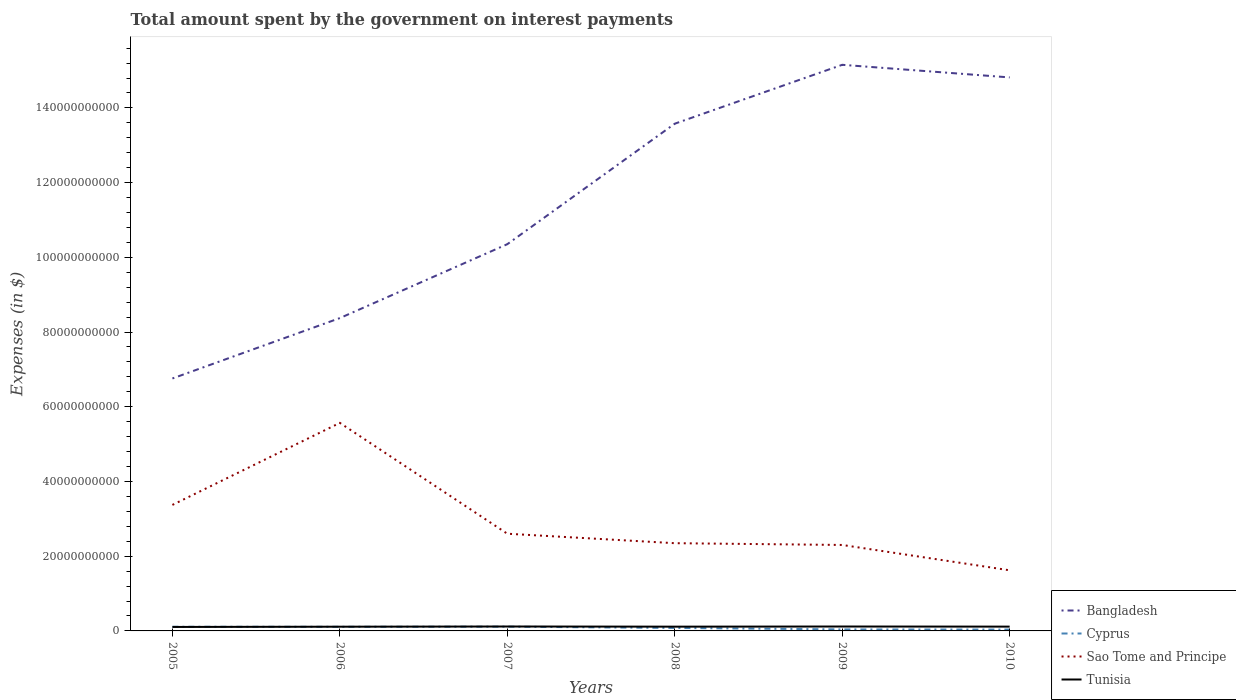Does the line corresponding to Tunisia intersect with the line corresponding to Cyprus?
Provide a succinct answer. Yes. Is the number of lines equal to the number of legend labels?
Offer a very short reply. Yes. Across all years, what is the maximum amount spent on interest payments by the government in Tunisia?
Your answer should be very brief. 1.06e+09. What is the total amount spent on interest payments by the government in Bangladesh in the graph?
Make the answer very short. -1.98e+1. What is the difference between the highest and the second highest amount spent on interest payments by the government in Sao Tome and Principe?
Ensure brevity in your answer.  3.95e+1. What is the difference between the highest and the lowest amount spent on interest payments by the government in Tunisia?
Offer a very short reply. 4. What is the difference between two consecutive major ticks on the Y-axis?
Your response must be concise. 2.00e+1. Are the values on the major ticks of Y-axis written in scientific E-notation?
Provide a short and direct response. No. Does the graph contain any zero values?
Keep it short and to the point. No. How many legend labels are there?
Give a very brief answer. 4. How are the legend labels stacked?
Offer a very short reply. Vertical. What is the title of the graph?
Offer a terse response. Total amount spent by the government on interest payments. Does "Croatia" appear as one of the legend labels in the graph?
Your response must be concise. No. What is the label or title of the Y-axis?
Your answer should be very brief. Expenses (in $). What is the Expenses (in $) in Bangladesh in 2005?
Ensure brevity in your answer.  6.76e+1. What is the Expenses (in $) in Cyprus in 2005?
Keep it short and to the point. 1.11e+09. What is the Expenses (in $) of Sao Tome and Principe in 2005?
Your answer should be very brief. 3.37e+1. What is the Expenses (in $) in Tunisia in 2005?
Provide a short and direct response. 1.06e+09. What is the Expenses (in $) in Bangladesh in 2006?
Your response must be concise. 8.37e+1. What is the Expenses (in $) of Cyprus in 2006?
Offer a very short reply. 1.10e+09. What is the Expenses (in $) of Sao Tome and Principe in 2006?
Ensure brevity in your answer.  5.57e+1. What is the Expenses (in $) of Tunisia in 2006?
Your answer should be compact. 1.13e+09. What is the Expenses (in $) in Bangladesh in 2007?
Offer a very short reply. 1.04e+11. What is the Expenses (in $) of Cyprus in 2007?
Provide a succinct answer. 1.14e+09. What is the Expenses (in $) of Sao Tome and Principe in 2007?
Provide a succinct answer. 2.60e+1. What is the Expenses (in $) in Tunisia in 2007?
Make the answer very short. 1.18e+09. What is the Expenses (in $) of Bangladesh in 2008?
Make the answer very short. 1.36e+11. What is the Expenses (in $) in Cyprus in 2008?
Keep it short and to the point. 7.95e+08. What is the Expenses (in $) in Sao Tome and Principe in 2008?
Your answer should be compact. 2.35e+1. What is the Expenses (in $) of Tunisia in 2008?
Your answer should be compact. 1.14e+09. What is the Expenses (in $) of Bangladesh in 2009?
Provide a short and direct response. 1.52e+11. What is the Expenses (in $) in Cyprus in 2009?
Offer a terse response. 4.03e+08. What is the Expenses (in $) in Sao Tome and Principe in 2009?
Provide a succinct answer. 2.30e+1. What is the Expenses (in $) in Tunisia in 2009?
Your answer should be compact. 1.18e+09. What is the Expenses (in $) in Bangladesh in 2010?
Offer a very short reply. 1.48e+11. What is the Expenses (in $) of Cyprus in 2010?
Your response must be concise. 3.62e+08. What is the Expenses (in $) in Sao Tome and Principe in 2010?
Your response must be concise. 1.62e+1. What is the Expenses (in $) of Tunisia in 2010?
Offer a very short reply. 1.15e+09. Across all years, what is the maximum Expenses (in $) of Bangladesh?
Keep it short and to the point. 1.52e+11. Across all years, what is the maximum Expenses (in $) in Cyprus?
Offer a very short reply. 1.14e+09. Across all years, what is the maximum Expenses (in $) of Sao Tome and Principe?
Give a very brief answer. 5.57e+1. Across all years, what is the maximum Expenses (in $) in Tunisia?
Offer a very short reply. 1.18e+09. Across all years, what is the minimum Expenses (in $) of Bangladesh?
Your answer should be very brief. 6.76e+1. Across all years, what is the minimum Expenses (in $) in Cyprus?
Give a very brief answer. 3.62e+08. Across all years, what is the minimum Expenses (in $) of Sao Tome and Principe?
Provide a short and direct response. 1.62e+1. Across all years, what is the minimum Expenses (in $) in Tunisia?
Your answer should be compact. 1.06e+09. What is the total Expenses (in $) in Bangladesh in the graph?
Ensure brevity in your answer.  6.90e+11. What is the total Expenses (in $) of Cyprus in the graph?
Your answer should be very brief. 4.92e+09. What is the total Expenses (in $) in Sao Tome and Principe in the graph?
Offer a very short reply. 1.78e+11. What is the total Expenses (in $) of Tunisia in the graph?
Provide a succinct answer. 6.85e+09. What is the difference between the Expenses (in $) of Bangladesh in 2005 and that in 2006?
Ensure brevity in your answer.  -1.62e+1. What is the difference between the Expenses (in $) in Cyprus in 2005 and that in 2006?
Make the answer very short. 1.20e+07. What is the difference between the Expenses (in $) in Sao Tome and Principe in 2005 and that in 2006?
Give a very brief answer. -2.20e+1. What is the difference between the Expenses (in $) in Tunisia in 2005 and that in 2006?
Keep it short and to the point. -6.77e+07. What is the difference between the Expenses (in $) in Bangladesh in 2005 and that in 2007?
Your answer should be compact. -3.59e+1. What is the difference between the Expenses (in $) of Cyprus in 2005 and that in 2007?
Offer a terse response. -2.79e+07. What is the difference between the Expenses (in $) of Sao Tome and Principe in 2005 and that in 2007?
Your response must be concise. 7.71e+09. What is the difference between the Expenses (in $) in Tunisia in 2005 and that in 2007?
Your answer should be very brief. -1.20e+08. What is the difference between the Expenses (in $) in Bangladesh in 2005 and that in 2008?
Give a very brief answer. -6.82e+1. What is the difference between the Expenses (in $) of Cyprus in 2005 and that in 2008?
Give a very brief answer. 3.19e+08. What is the difference between the Expenses (in $) in Sao Tome and Principe in 2005 and that in 2008?
Ensure brevity in your answer.  1.02e+1. What is the difference between the Expenses (in $) in Tunisia in 2005 and that in 2008?
Offer a very short reply. -8.04e+07. What is the difference between the Expenses (in $) in Bangladesh in 2005 and that in 2009?
Your response must be concise. -8.40e+1. What is the difference between the Expenses (in $) of Cyprus in 2005 and that in 2009?
Keep it short and to the point. 7.11e+08. What is the difference between the Expenses (in $) in Sao Tome and Principe in 2005 and that in 2009?
Provide a succinct answer. 1.07e+1. What is the difference between the Expenses (in $) in Tunisia in 2005 and that in 2009?
Ensure brevity in your answer.  -1.18e+08. What is the difference between the Expenses (in $) in Bangladesh in 2005 and that in 2010?
Provide a short and direct response. -8.06e+1. What is the difference between the Expenses (in $) in Cyprus in 2005 and that in 2010?
Offer a very short reply. 7.53e+08. What is the difference between the Expenses (in $) of Sao Tome and Principe in 2005 and that in 2010?
Give a very brief answer. 1.75e+1. What is the difference between the Expenses (in $) in Tunisia in 2005 and that in 2010?
Give a very brief answer. -8.99e+07. What is the difference between the Expenses (in $) in Bangladesh in 2006 and that in 2007?
Your answer should be very brief. -1.98e+1. What is the difference between the Expenses (in $) of Cyprus in 2006 and that in 2007?
Make the answer very short. -3.98e+07. What is the difference between the Expenses (in $) in Sao Tome and Principe in 2006 and that in 2007?
Your response must be concise. 2.97e+1. What is the difference between the Expenses (in $) of Tunisia in 2006 and that in 2007?
Ensure brevity in your answer.  -5.21e+07. What is the difference between the Expenses (in $) in Bangladesh in 2006 and that in 2008?
Keep it short and to the point. -5.20e+1. What is the difference between the Expenses (in $) of Cyprus in 2006 and that in 2008?
Your answer should be very brief. 3.07e+08. What is the difference between the Expenses (in $) in Sao Tome and Principe in 2006 and that in 2008?
Offer a very short reply. 3.22e+1. What is the difference between the Expenses (in $) in Tunisia in 2006 and that in 2008?
Keep it short and to the point. -1.27e+07. What is the difference between the Expenses (in $) of Bangladesh in 2006 and that in 2009?
Keep it short and to the point. -6.78e+1. What is the difference between the Expenses (in $) in Cyprus in 2006 and that in 2009?
Keep it short and to the point. 6.99e+08. What is the difference between the Expenses (in $) of Sao Tome and Principe in 2006 and that in 2009?
Your answer should be compact. 3.27e+1. What is the difference between the Expenses (in $) in Tunisia in 2006 and that in 2009?
Keep it short and to the point. -5.03e+07. What is the difference between the Expenses (in $) of Bangladesh in 2006 and that in 2010?
Provide a short and direct response. -6.44e+1. What is the difference between the Expenses (in $) of Cyprus in 2006 and that in 2010?
Provide a succinct answer. 7.41e+08. What is the difference between the Expenses (in $) in Sao Tome and Principe in 2006 and that in 2010?
Ensure brevity in your answer.  3.95e+1. What is the difference between the Expenses (in $) in Tunisia in 2006 and that in 2010?
Your response must be concise. -2.22e+07. What is the difference between the Expenses (in $) of Bangladesh in 2007 and that in 2008?
Offer a terse response. -3.23e+1. What is the difference between the Expenses (in $) in Cyprus in 2007 and that in 2008?
Your response must be concise. 3.47e+08. What is the difference between the Expenses (in $) of Sao Tome and Principe in 2007 and that in 2008?
Provide a succinct answer. 2.54e+09. What is the difference between the Expenses (in $) of Tunisia in 2007 and that in 2008?
Your response must be concise. 3.94e+07. What is the difference between the Expenses (in $) in Bangladesh in 2007 and that in 2009?
Your answer should be compact. -4.80e+1. What is the difference between the Expenses (in $) of Cyprus in 2007 and that in 2009?
Offer a very short reply. 7.39e+08. What is the difference between the Expenses (in $) of Sao Tome and Principe in 2007 and that in 2009?
Give a very brief answer. 3.01e+09. What is the difference between the Expenses (in $) of Tunisia in 2007 and that in 2009?
Provide a short and direct response. 1.80e+06. What is the difference between the Expenses (in $) of Bangladesh in 2007 and that in 2010?
Your response must be concise. -4.46e+1. What is the difference between the Expenses (in $) in Cyprus in 2007 and that in 2010?
Your response must be concise. 7.80e+08. What is the difference between the Expenses (in $) of Sao Tome and Principe in 2007 and that in 2010?
Your response must be concise. 9.79e+09. What is the difference between the Expenses (in $) of Tunisia in 2007 and that in 2010?
Make the answer very short. 2.99e+07. What is the difference between the Expenses (in $) of Bangladesh in 2008 and that in 2009?
Your answer should be very brief. -1.58e+1. What is the difference between the Expenses (in $) in Cyprus in 2008 and that in 2009?
Offer a very short reply. 3.92e+08. What is the difference between the Expenses (in $) in Sao Tome and Principe in 2008 and that in 2009?
Your answer should be compact. 4.73e+08. What is the difference between the Expenses (in $) in Tunisia in 2008 and that in 2009?
Your answer should be compact. -3.76e+07. What is the difference between the Expenses (in $) in Bangladesh in 2008 and that in 2010?
Ensure brevity in your answer.  -1.24e+1. What is the difference between the Expenses (in $) of Cyprus in 2008 and that in 2010?
Your answer should be compact. 4.34e+08. What is the difference between the Expenses (in $) of Sao Tome and Principe in 2008 and that in 2010?
Keep it short and to the point. 7.26e+09. What is the difference between the Expenses (in $) of Tunisia in 2008 and that in 2010?
Keep it short and to the point. -9.50e+06. What is the difference between the Expenses (in $) in Bangladesh in 2009 and that in 2010?
Offer a very short reply. 3.37e+09. What is the difference between the Expenses (in $) in Cyprus in 2009 and that in 2010?
Offer a terse response. 4.11e+07. What is the difference between the Expenses (in $) in Sao Tome and Principe in 2009 and that in 2010?
Make the answer very short. 6.78e+09. What is the difference between the Expenses (in $) in Tunisia in 2009 and that in 2010?
Give a very brief answer. 2.81e+07. What is the difference between the Expenses (in $) in Bangladesh in 2005 and the Expenses (in $) in Cyprus in 2006?
Give a very brief answer. 6.65e+1. What is the difference between the Expenses (in $) of Bangladesh in 2005 and the Expenses (in $) of Sao Tome and Principe in 2006?
Give a very brief answer. 1.19e+1. What is the difference between the Expenses (in $) in Bangladesh in 2005 and the Expenses (in $) in Tunisia in 2006?
Provide a short and direct response. 6.64e+1. What is the difference between the Expenses (in $) of Cyprus in 2005 and the Expenses (in $) of Sao Tome and Principe in 2006?
Offer a very short reply. -5.46e+1. What is the difference between the Expenses (in $) in Cyprus in 2005 and the Expenses (in $) in Tunisia in 2006?
Provide a short and direct response. -1.58e+07. What is the difference between the Expenses (in $) in Sao Tome and Principe in 2005 and the Expenses (in $) in Tunisia in 2006?
Keep it short and to the point. 3.26e+1. What is the difference between the Expenses (in $) of Bangladesh in 2005 and the Expenses (in $) of Cyprus in 2007?
Your response must be concise. 6.64e+1. What is the difference between the Expenses (in $) in Bangladesh in 2005 and the Expenses (in $) in Sao Tome and Principe in 2007?
Make the answer very short. 4.16e+1. What is the difference between the Expenses (in $) in Bangladesh in 2005 and the Expenses (in $) in Tunisia in 2007?
Offer a terse response. 6.64e+1. What is the difference between the Expenses (in $) of Cyprus in 2005 and the Expenses (in $) of Sao Tome and Principe in 2007?
Provide a short and direct response. -2.49e+1. What is the difference between the Expenses (in $) of Cyprus in 2005 and the Expenses (in $) of Tunisia in 2007?
Your response must be concise. -6.79e+07. What is the difference between the Expenses (in $) in Sao Tome and Principe in 2005 and the Expenses (in $) in Tunisia in 2007?
Offer a terse response. 3.25e+1. What is the difference between the Expenses (in $) in Bangladesh in 2005 and the Expenses (in $) in Cyprus in 2008?
Offer a very short reply. 6.68e+1. What is the difference between the Expenses (in $) of Bangladesh in 2005 and the Expenses (in $) of Sao Tome and Principe in 2008?
Provide a short and direct response. 4.41e+1. What is the difference between the Expenses (in $) in Bangladesh in 2005 and the Expenses (in $) in Tunisia in 2008?
Provide a succinct answer. 6.64e+1. What is the difference between the Expenses (in $) of Cyprus in 2005 and the Expenses (in $) of Sao Tome and Principe in 2008?
Ensure brevity in your answer.  -2.24e+1. What is the difference between the Expenses (in $) of Cyprus in 2005 and the Expenses (in $) of Tunisia in 2008?
Keep it short and to the point. -2.85e+07. What is the difference between the Expenses (in $) of Sao Tome and Principe in 2005 and the Expenses (in $) of Tunisia in 2008?
Give a very brief answer. 3.26e+1. What is the difference between the Expenses (in $) of Bangladesh in 2005 and the Expenses (in $) of Cyprus in 2009?
Ensure brevity in your answer.  6.72e+1. What is the difference between the Expenses (in $) in Bangladesh in 2005 and the Expenses (in $) in Sao Tome and Principe in 2009?
Ensure brevity in your answer.  4.46e+1. What is the difference between the Expenses (in $) of Bangladesh in 2005 and the Expenses (in $) of Tunisia in 2009?
Keep it short and to the point. 6.64e+1. What is the difference between the Expenses (in $) of Cyprus in 2005 and the Expenses (in $) of Sao Tome and Principe in 2009?
Your answer should be very brief. -2.19e+1. What is the difference between the Expenses (in $) in Cyprus in 2005 and the Expenses (in $) in Tunisia in 2009?
Ensure brevity in your answer.  -6.61e+07. What is the difference between the Expenses (in $) in Sao Tome and Principe in 2005 and the Expenses (in $) in Tunisia in 2009?
Make the answer very short. 3.25e+1. What is the difference between the Expenses (in $) in Bangladesh in 2005 and the Expenses (in $) in Cyprus in 2010?
Your answer should be compact. 6.72e+1. What is the difference between the Expenses (in $) in Bangladesh in 2005 and the Expenses (in $) in Sao Tome and Principe in 2010?
Keep it short and to the point. 5.14e+1. What is the difference between the Expenses (in $) of Bangladesh in 2005 and the Expenses (in $) of Tunisia in 2010?
Your response must be concise. 6.64e+1. What is the difference between the Expenses (in $) of Cyprus in 2005 and the Expenses (in $) of Sao Tome and Principe in 2010?
Your response must be concise. -1.51e+1. What is the difference between the Expenses (in $) of Cyprus in 2005 and the Expenses (in $) of Tunisia in 2010?
Offer a terse response. -3.80e+07. What is the difference between the Expenses (in $) of Sao Tome and Principe in 2005 and the Expenses (in $) of Tunisia in 2010?
Your response must be concise. 3.26e+1. What is the difference between the Expenses (in $) of Bangladesh in 2006 and the Expenses (in $) of Cyprus in 2007?
Offer a terse response. 8.26e+1. What is the difference between the Expenses (in $) in Bangladesh in 2006 and the Expenses (in $) in Sao Tome and Principe in 2007?
Offer a terse response. 5.77e+1. What is the difference between the Expenses (in $) of Bangladesh in 2006 and the Expenses (in $) of Tunisia in 2007?
Your response must be concise. 8.26e+1. What is the difference between the Expenses (in $) in Cyprus in 2006 and the Expenses (in $) in Sao Tome and Principe in 2007?
Ensure brevity in your answer.  -2.49e+1. What is the difference between the Expenses (in $) in Cyprus in 2006 and the Expenses (in $) in Tunisia in 2007?
Give a very brief answer. -7.99e+07. What is the difference between the Expenses (in $) in Sao Tome and Principe in 2006 and the Expenses (in $) in Tunisia in 2007?
Provide a succinct answer. 5.45e+1. What is the difference between the Expenses (in $) of Bangladesh in 2006 and the Expenses (in $) of Cyprus in 2008?
Offer a very short reply. 8.29e+1. What is the difference between the Expenses (in $) in Bangladesh in 2006 and the Expenses (in $) in Sao Tome and Principe in 2008?
Your answer should be very brief. 6.03e+1. What is the difference between the Expenses (in $) in Bangladesh in 2006 and the Expenses (in $) in Tunisia in 2008?
Offer a terse response. 8.26e+1. What is the difference between the Expenses (in $) in Cyprus in 2006 and the Expenses (in $) in Sao Tome and Principe in 2008?
Offer a terse response. -2.24e+1. What is the difference between the Expenses (in $) of Cyprus in 2006 and the Expenses (in $) of Tunisia in 2008?
Make the answer very short. -4.05e+07. What is the difference between the Expenses (in $) in Sao Tome and Principe in 2006 and the Expenses (in $) in Tunisia in 2008?
Your response must be concise. 5.45e+1. What is the difference between the Expenses (in $) in Bangladesh in 2006 and the Expenses (in $) in Cyprus in 2009?
Provide a short and direct response. 8.33e+1. What is the difference between the Expenses (in $) of Bangladesh in 2006 and the Expenses (in $) of Sao Tome and Principe in 2009?
Offer a terse response. 6.07e+1. What is the difference between the Expenses (in $) of Bangladesh in 2006 and the Expenses (in $) of Tunisia in 2009?
Give a very brief answer. 8.26e+1. What is the difference between the Expenses (in $) of Cyprus in 2006 and the Expenses (in $) of Sao Tome and Principe in 2009?
Give a very brief answer. -2.19e+1. What is the difference between the Expenses (in $) in Cyprus in 2006 and the Expenses (in $) in Tunisia in 2009?
Your response must be concise. -7.81e+07. What is the difference between the Expenses (in $) of Sao Tome and Principe in 2006 and the Expenses (in $) of Tunisia in 2009?
Provide a short and direct response. 5.45e+1. What is the difference between the Expenses (in $) in Bangladesh in 2006 and the Expenses (in $) in Cyprus in 2010?
Provide a short and direct response. 8.34e+1. What is the difference between the Expenses (in $) of Bangladesh in 2006 and the Expenses (in $) of Sao Tome and Principe in 2010?
Your answer should be compact. 6.75e+1. What is the difference between the Expenses (in $) in Bangladesh in 2006 and the Expenses (in $) in Tunisia in 2010?
Your answer should be very brief. 8.26e+1. What is the difference between the Expenses (in $) of Cyprus in 2006 and the Expenses (in $) of Sao Tome and Principe in 2010?
Your answer should be very brief. -1.51e+1. What is the difference between the Expenses (in $) of Cyprus in 2006 and the Expenses (in $) of Tunisia in 2010?
Provide a short and direct response. -5.00e+07. What is the difference between the Expenses (in $) in Sao Tome and Principe in 2006 and the Expenses (in $) in Tunisia in 2010?
Your response must be concise. 5.45e+1. What is the difference between the Expenses (in $) of Bangladesh in 2007 and the Expenses (in $) of Cyprus in 2008?
Your answer should be compact. 1.03e+11. What is the difference between the Expenses (in $) of Bangladesh in 2007 and the Expenses (in $) of Sao Tome and Principe in 2008?
Keep it short and to the point. 8.00e+1. What is the difference between the Expenses (in $) in Bangladesh in 2007 and the Expenses (in $) in Tunisia in 2008?
Give a very brief answer. 1.02e+11. What is the difference between the Expenses (in $) in Cyprus in 2007 and the Expenses (in $) in Sao Tome and Principe in 2008?
Your answer should be compact. -2.23e+1. What is the difference between the Expenses (in $) in Cyprus in 2007 and the Expenses (in $) in Tunisia in 2008?
Offer a terse response. -6.42e+05. What is the difference between the Expenses (in $) in Sao Tome and Principe in 2007 and the Expenses (in $) in Tunisia in 2008?
Your answer should be very brief. 2.49e+1. What is the difference between the Expenses (in $) in Bangladesh in 2007 and the Expenses (in $) in Cyprus in 2009?
Your response must be concise. 1.03e+11. What is the difference between the Expenses (in $) of Bangladesh in 2007 and the Expenses (in $) of Sao Tome and Principe in 2009?
Ensure brevity in your answer.  8.05e+1. What is the difference between the Expenses (in $) of Bangladesh in 2007 and the Expenses (in $) of Tunisia in 2009?
Offer a very short reply. 1.02e+11. What is the difference between the Expenses (in $) in Cyprus in 2007 and the Expenses (in $) in Sao Tome and Principe in 2009?
Your response must be concise. -2.19e+1. What is the difference between the Expenses (in $) of Cyprus in 2007 and the Expenses (in $) of Tunisia in 2009?
Provide a short and direct response. -3.82e+07. What is the difference between the Expenses (in $) of Sao Tome and Principe in 2007 and the Expenses (in $) of Tunisia in 2009?
Your answer should be compact. 2.48e+1. What is the difference between the Expenses (in $) of Bangladesh in 2007 and the Expenses (in $) of Cyprus in 2010?
Provide a succinct answer. 1.03e+11. What is the difference between the Expenses (in $) of Bangladesh in 2007 and the Expenses (in $) of Sao Tome and Principe in 2010?
Give a very brief answer. 8.73e+1. What is the difference between the Expenses (in $) of Bangladesh in 2007 and the Expenses (in $) of Tunisia in 2010?
Your response must be concise. 1.02e+11. What is the difference between the Expenses (in $) of Cyprus in 2007 and the Expenses (in $) of Sao Tome and Principe in 2010?
Make the answer very short. -1.51e+1. What is the difference between the Expenses (in $) in Cyprus in 2007 and the Expenses (in $) in Tunisia in 2010?
Ensure brevity in your answer.  -1.01e+07. What is the difference between the Expenses (in $) of Sao Tome and Principe in 2007 and the Expenses (in $) of Tunisia in 2010?
Your response must be concise. 2.49e+1. What is the difference between the Expenses (in $) of Bangladesh in 2008 and the Expenses (in $) of Cyprus in 2009?
Ensure brevity in your answer.  1.35e+11. What is the difference between the Expenses (in $) of Bangladesh in 2008 and the Expenses (in $) of Sao Tome and Principe in 2009?
Provide a short and direct response. 1.13e+11. What is the difference between the Expenses (in $) in Bangladesh in 2008 and the Expenses (in $) in Tunisia in 2009?
Provide a succinct answer. 1.35e+11. What is the difference between the Expenses (in $) in Cyprus in 2008 and the Expenses (in $) in Sao Tome and Principe in 2009?
Ensure brevity in your answer.  -2.22e+1. What is the difference between the Expenses (in $) in Cyprus in 2008 and the Expenses (in $) in Tunisia in 2009?
Offer a very short reply. -3.85e+08. What is the difference between the Expenses (in $) in Sao Tome and Principe in 2008 and the Expenses (in $) in Tunisia in 2009?
Provide a succinct answer. 2.23e+1. What is the difference between the Expenses (in $) in Bangladesh in 2008 and the Expenses (in $) in Cyprus in 2010?
Ensure brevity in your answer.  1.35e+11. What is the difference between the Expenses (in $) in Bangladesh in 2008 and the Expenses (in $) in Sao Tome and Principe in 2010?
Provide a short and direct response. 1.20e+11. What is the difference between the Expenses (in $) of Bangladesh in 2008 and the Expenses (in $) of Tunisia in 2010?
Ensure brevity in your answer.  1.35e+11. What is the difference between the Expenses (in $) in Cyprus in 2008 and the Expenses (in $) in Sao Tome and Principe in 2010?
Your response must be concise. -1.54e+1. What is the difference between the Expenses (in $) of Cyprus in 2008 and the Expenses (in $) of Tunisia in 2010?
Offer a very short reply. -3.57e+08. What is the difference between the Expenses (in $) in Sao Tome and Principe in 2008 and the Expenses (in $) in Tunisia in 2010?
Make the answer very short. 2.23e+1. What is the difference between the Expenses (in $) of Bangladesh in 2009 and the Expenses (in $) of Cyprus in 2010?
Your response must be concise. 1.51e+11. What is the difference between the Expenses (in $) of Bangladesh in 2009 and the Expenses (in $) of Sao Tome and Principe in 2010?
Ensure brevity in your answer.  1.35e+11. What is the difference between the Expenses (in $) of Bangladesh in 2009 and the Expenses (in $) of Tunisia in 2010?
Provide a succinct answer. 1.50e+11. What is the difference between the Expenses (in $) of Cyprus in 2009 and the Expenses (in $) of Sao Tome and Principe in 2010?
Make the answer very short. -1.58e+1. What is the difference between the Expenses (in $) in Cyprus in 2009 and the Expenses (in $) in Tunisia in 2010?
Offer a very short reply. -7.49e+08. What is the difference between the Expenses (in $) of Sao Tome and Principe in 2009 and the Expenses (in $) of Tunisia in 2010?
Offer a very short reply. 2.19e+1. What is the average Expenses (in $) in Bangladesh per year?
Give a very brief answer. 1.15e+11. What is the average Expenses (in $) of Cyprus per year?
Offer a very short reply. 8.20e+08. What is the average Expenses (in $) in Sao Tome and Principe per year?
Provide a succinct answer. 2.97e+1. What is the average Expenses (in $) in Tunisia per year?
Ensure brevity in your answer.  1.14e+09. In the year 2005, what is the difference between the Expenses (in $) in Bangladesh and Expenses (in $) in Cyprus?
Ensure brevity in your answer.  6.65e+1. In the year 2005, what is the difference between the Expenses (in $) of Bangladesh and Expenses (in $) of Sao Tome and Principe?
Offer a very short reply. 3.38e+1. In the year 2005, what is the difference between the Expenses (in $) of Bangladesh and Expenses (in $) of Tunisia?
Provide a succinct answer. 6.65e+1. In the year 2005, what is the difference between the Expenses (in $) of Cyprus and Expenses (in $) of Sao Tome and Principe?
Ensure brevity in your answer.  -3.26e+1. In the year 2005, what is the difference between the Expenses (in $) of Cyprus and Expenses (in $) of Tunisia?
Your response must be concise. 5.19e+07. In the year 2005, what is the difference between the Expenses (in $) in Sao Tome and Principe and Expenses (in $) in Tunisia?
Your answer should be very brief. 3.27e+1. In the year 2006, what is the difference between the Expenses (in $) in Bangladesh and Expenses (in $) in Cyprus?
Your answer should be very brief. 8.26e+1. In the year 2006, what is the difference between the Expenses (in $) in Bangladesh and Expenses (in $) in Sao Tome and Principe?
Offer a very short reply. 2.80e+1. In the year 2006, what is the difference between the Expenses (in $) in Bangladesh and Expenses (in $) in Tunisia?
Provide a succinct answer. 8.26e+1. In the year 2006, what is the difference between the Expenses (in $) in Cyprus and Expenses (in $) in Sao Tome and Principe?
Give a very brief answer. -5.46e+1. In the year 2006, what is the difference between the Expenses (in $) in Cyprus and Expenses (in $) in Tunisia?
Your response must be concise. -2.78e+07. In the year 2006, what is the difference between the Expenses (in $) in Sao Tome and Principe and Expenses (in $) in Tunisia?
Make the answer very short. 5.46e+1. In the year 2007, what is the difference between the Expenses (in $) of Bangladesh and Expenses (in $) of Cyprus?
Provide a short and direct response. 1.02e+11. In the year 2007, what is the difference between the Expenses (in $) in Bangladesh and Expenses (in $) in Sao Tome and Principe?
Provide a short and direct response. 7.75e+1. In the year 2007, what is the difference between the Expenses (in $) of Bangladesh and Expenses (in $) of Tunisia?
Ensure brevity in your answer.  1.02e+11. In the year 2007, what is the difference between the Expenses (in $) in Cyprus and Expenses (in $) in Sao Tome and Principe?
Your answer should be compact. -2.49e+1. In the year 2007, what is the difference between the Expenses (in $) in Cyprus and Expenses (in $) in Tunisia?
Your answer should be very brief. -4.00e+07. In the year 2007, what is the difference between the Expenses (in $) of Sao Tome and Principe and Expenses (in $) of Tunisia?
Provide a short and direct response. 2.48e+1. In the year 2008, what is the difference between the Expenses (in $) in Bangladesh and Expenses (in $) in Cyprus?
Ensure brevity in your answer.  1.35e+11. In the year 2008, what is the difference between the Expenses (in $) of Bangladesh and Expenses (in $) of Sao Tome and Principe?
Provide a short and direct response. 1.12e+11. In the year 2008, what is the difference between the Expenses (in $) of Bangladesh and Expenses (in $) of Tunisia?
Give a very brief answer. 1.35e+11. In the year 2008, what is the difference between the Expenses (in $) in Cyprus and Expenses (in $) in Sao Tome and Principe?
Keep it short and to the point. -2.27e+1. In the year 2008, what is the difference between the Expenses (in $) of Cyprus and Expenses (in $) of Tunisia?
Offer a very short reply. -3.47e+08. In the year 2008, what is the difference between the Expenses (in $) in Sao Tome and Principe and Expenses (in $) in Tunisia?
Your answer should be very brief. 2.23e+1. In the year 2009, what is the difference between the Expenses (in $) in Bangladesh and Expenses (in $) in Cyprus?
Offer a terse response. 1.51e+11. In the year 2009, what is the difference between the Expenses (in $) in Bangladesh and Expenses (in $) in Sao Tome and Principe?
Ensure brevity in your answer.  1.29e+11. In the year 2009, what is the difference between the Expenses (in $) of Bangladesh and Expenses (in $) of Tunisia?
Offer a terse response. 1.50e+11. In the year 2009, what is the difference between the Expenses (in $) of Cyprus and Expenses (in $) of Sao Tome and Principe?
Offer a very short reply. -2.26e+1. In the year 2009, what is the difference between the Expenses (in $) of Cyprus and Expenses (in $) of Tunisia?
Offer a very short reply. -7.78e+08. In the year 2009, what is the difference between the Expenses (in $) in Sao Tome and Principe and Expenses (in $) in Tunisia?
Provide a short and direct response. 2.18e+1. In the year 2010, what is the difference between the Expenses (in $) in Bangladesh and Expenses (in $) in Cyprus?
Offer a terse response. 1.48e+11. In the year 2010, what is the difference between the Expenses (in $) in Bangladesh and Expenses (in $) in Sao Tome and Principe?
Make the answer very short. 1.32e+11. In the year 2010, what is the difference between the Expenses (in $) in Bangladesh and Expenses (in $) in Tunisia?
Provide a succinct answer. 1.47e+11. In the year 2010, what is the difference between the Expenses (in $) in Cyprus and Expenses (in $) in Sao Tome and Principe?
Provide a succinct answer. -1.59e+1. In the year 2010, what is the difference between the Expenses (in $) of Cyprus and Expenses (in $) of Tunisia?
Keep it short and to the point. -7.90e+08. In the year 2010, what is the difference between the Expenses (in $) of Sao Tome and Principe and Expenses (in $) of Tunisia?
Give a very brief answer. 1.51e+1. What is the ratio of the Expenses (in $) in Bangladesh in 2005 to that in 2006?
Offer a very short reply. 0.81. What is the ratio of the Expenses (in $) of Cyprus in 2005 to that in 2006?
Keep it short and to the point. 1.01. What is the ratio of the Expenses (in $) of Sao Tome and Principe in 2005 to that in 2006?
Keep it short and to the point. 0.61. What is the ratio of the Expenses (in $) of Tunisia in 2005 to that in 2006?
Ensure brevity in your answer.  0.94. What is the ratio of the Expenses (in $) of Bangladesh in 2005 to that in 2007?
Offer a very short reply. 0.65. What is the ratio of the Expenses (in $) of Cyprus in 2005 to that in 2007?
Keep it short and to the point. 0.98. What is the ratio of the Expenses (in $) in Sao Tome and Principe in 2005 to that in 2007?
Provide a succinct answer. 1.3. What is the ratio of the Expenses (in $) in Tunisia in 2005 to that in 2007?
Make the answer very short. 0.9. What is the ratio of the Expenses (in $) of Bangladesh in 2005 to that in 2008?
Make the answer very short. 0.5. What is the ratio of the Expenses (in $) in Cyprus in 2005 to that in 2008?
Your answer should be compact. 1.4. What is the ratio of the Expenses (in $) of Sao Tome and Principe in 2005 to that in 2008?
Provide a succinct answer. 1.44. What is the ratio of the Expenses (in $) of Tunisia in 2005 to that in 2008?
Make the answer very short. 0.93. What is the ratio of the Expenses (in $) in Bangladesh in 2005 to that in 2009?
Keep it short and to the point. 0.45. What is the ratio of the Expenses (in $) in Cyprus in 2005 to that in 2009?
Offer a very short reply. 2.77. What is the ratio of the Expenses (in $) of Sao Tome and Principe in 2005 to that in 2009?
Your answer should be very brief. 1.47. What is the ratio of the Expenses (in $) of Bangladesh in 2005 to that in 2010?
Make the answer very short. 0.46. What is the ratio of the Expenses (in $) of Cyprus in 2005 to that in 2010?
Offer a very short reply. 3.08. What is the ratio of the Expenses (in $) in Sao Tome and Principe in 2005 to that in 2010?
Your answer should be very brief. 2.08. What is the ratio of the Expenses (in $) of Tunisia in 2005 to that in 2010?
Offer a terse response. 0.92. What is the ratio of the Expenses (in $) of Bangladesh in 2006 to that in 2007?
Offer a very short reply. 0.81. What is the ratio of the Expenses (in $) in Cyprus in 2006 to that in 2007?
Give a very brief answer. 0.97. What is the ratio of the Expenses (in $) of Sao Tome and Principe in 2006 to that in 2007?
Make the answer very short. 2.14. What is the ratio of the Expenses (in $) in Tunisia in 2006 to that in 2007?
Ensure brevity in your answer.  0.96. What is the ratio of the Expenses (in $) of Bangladesh in 2006 to that in 2008?
Make the answer very short. 0.62. What is the ratio of the Expenses (in $) of Cyprus in 2006 to that in 2008?
Provide a short and direct response. 1.39. What is the ratio of the Expenses (in $) of Sao Tome and Principe in 2006 to that in 2008?
Ensure brevity in your answer.  2.37. What is the ratio of the Expenses (in $) in Tunisia in 2006 to that in 2008?
Provide a succinct answer. 0.99. What is the ratio of the Expenses (in $) in Bangladesh in 2006 to that in 2009?
Offer a very short reply. 0.55. What is the ratio of the Expenses (in $) of Cyprus in 2006 to that in 2009?
Offer a terse response. 2.74. What is the ratio of the Expenses (in $) of Sao Tome and Principe in 2006 to that in 2009?
Offer a terse response. 2.42. What is the ratio of the Expenses (in $) in Tunisia in 2006 to that in 2009?
Offer a very short reply. 0.96. What is the ratio of the Expenses (in $) of Bangladesh in 2006 to that in 2010?
Your response must be concise. 0.57. What is the ratio of the Expenses (in $) in Cyprus in 2006 to that in 2010?
Keep it short and to the point. 3.05. What is the ratio of the Expenses (in $) of Sao Tome and Principe in 2006 to that in 2010?
Your response must be concise. 3.43. What is the ratio of the Expenses (in $) of Tunisia in 2006 to that in 2010?
Your answer should be compact. 0.98. What is the ratio of the Expenses (in $) of Bangladesh in 2007 to that in 2008?
Ensure brevity in your answer.  0.76. What is the ratio of the Expenses (in $) of Cyprus in 2007 to that in 2008?
Your answer should be very brief. 1.44. What is the ratio of the Expenses (in $) of Sao Tome and Principe in 2007 to that in 2008?
Keep it short and to the point. 1.11. What is the ratio of the Expenses (in $) in Tunisia in 2007 to that in 2008?
Make the answer very short. 1.03. What is the ratio of the Expenses (in $) of Bangladesh in 2007 to that in 2009?
Provide a short and direct response. 0.68. What is the ratio of the Expenses (in $) in Cyprus in 2007 to that in 2009?
Your response must be concise. 2.84. What is the ratio of the Expenses (in $) in Sao Tome and Principe in 2007 to that in 2009?
Your answer should be compact. 1.13. What is the ratio of the Expenses (in $) of Bangladesh in 2007 to that in 2010?
Your answer should be compact. 0.7. What is the ratio of the Expenses (in $) of Cyprus in 2007 to that in 2010?
Offer a terse response. 3.16. What is the ratio of the Expenses (in $) of Sao Tome and Principe in 2007 to that in 2010?
Offer a terse response. 1.6. What is the ratio of the Expenses (in $) of Bangladesh in 2008 to that in 2009?
Offer a very short reply. 0.9. What is the ratio of the Expenses (in $) of Cyprus in 2008 to that in 2009?
Offer a terse response. 1.97. What is the ratio of the Expenses (in $) in Sao Tome and Principe in 2008 to that in 2009?
Your answer should be compact. 1.02. What is the ratio of the Expenses (in $) of Tunisia in 2008 to that in 2009?
Offer a terse response. 0.97. What is the ratio of the Expenses (in $) in Bangladesh in 2008 to that in 2010?
Your response must be concise. 0.92. What is the ratio of the Expenses (in $) in Cyprus in 2008 to that in 2010?
Provide a short and direct response. 2.2. What is the ratio of the Expenses (in $) of Sao Tome and Principe in 2008 to that in 2010?
Give a very brief answer. 1.45. What is the ratio of the Expenses (in $) in Tunisia in 2008 to that in 2010?
Your answer should be very brief. 0.99. What is the ratio of the Expenses (in $) in Bangladesh in 2009 to that in 2010?
Offer a very short reply. 1.02. What is the ratio of the Expenses (in $) of Cyprus in 2009 to that in 2010?
Make the answer very short. 1.11. What is the ratio of the Expenses (in $) of Sao Tome and Principe in 2009 to that in 2010?
Ensure brevity in your answer.  1.42. What is the ratio of the Expenses (in $) in Tunisia in 2009 to that in 2010?
Your answer should be very brief. 1.02. What is the difference between the highest and the second highest Expenses (in $) in Bangladesh?
Provide a succinct answer. 3.37e+09. What is the difference between the highest and the second highest Expenses (in $) of Cyprus?
Make the answer very short. 2.79e+07. What is the difference between the highest and the second highest Expenses (in $) of Sao Tome and Principe?
Your answer should be very brief. 2.20e+1. What is the difference between the highest and the second highest Expenses (in $) of Tunisia?
Keep it short and to the point. 1.80e+06. What is the difference between the highest and the lowest Expenses (in $) of Bangladesh?
Offer a terse response. 8.40e+1. What is the difference between the highest and the lowest Expenses (in $) in Cyprus?
Keep it short and to the point. 7.80e+08. What is the difference between the highest and the lowest Expenses (in $) in Sao Tome and Principe?
Make the answer very short. 3.95e+1. What is the difference between the highest and the lowest Expenses (in $) in Tunisia?
Offer a very short reply. 1.20e+08. 